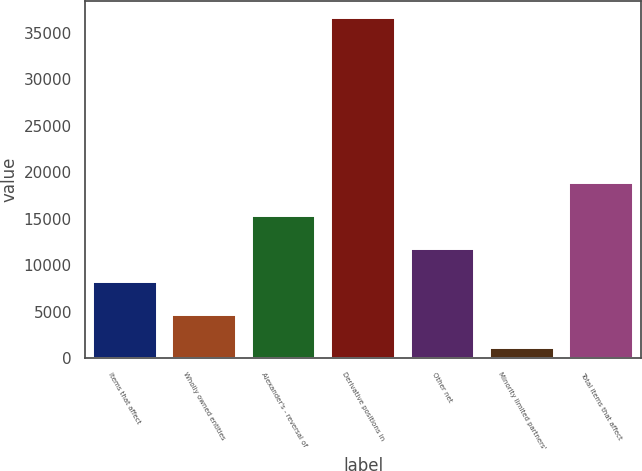Convert chart to OTSL. <chart><loc_0><loc_0><loc_500><loc_500><bar_chart><fcel>Items that affect<fcel>Wholly owned entities<fcel>Alexander's - reversal of<fcel>Derivative positions in<fcel>Other net<fcel>Minority limited partners'<fcel>Total items that affect<nl><fcel>8197<fcel>4655<fcel>15281<fcel>36533<fcel>11739<fcel>1113<fcel>18823<nl></chart> 